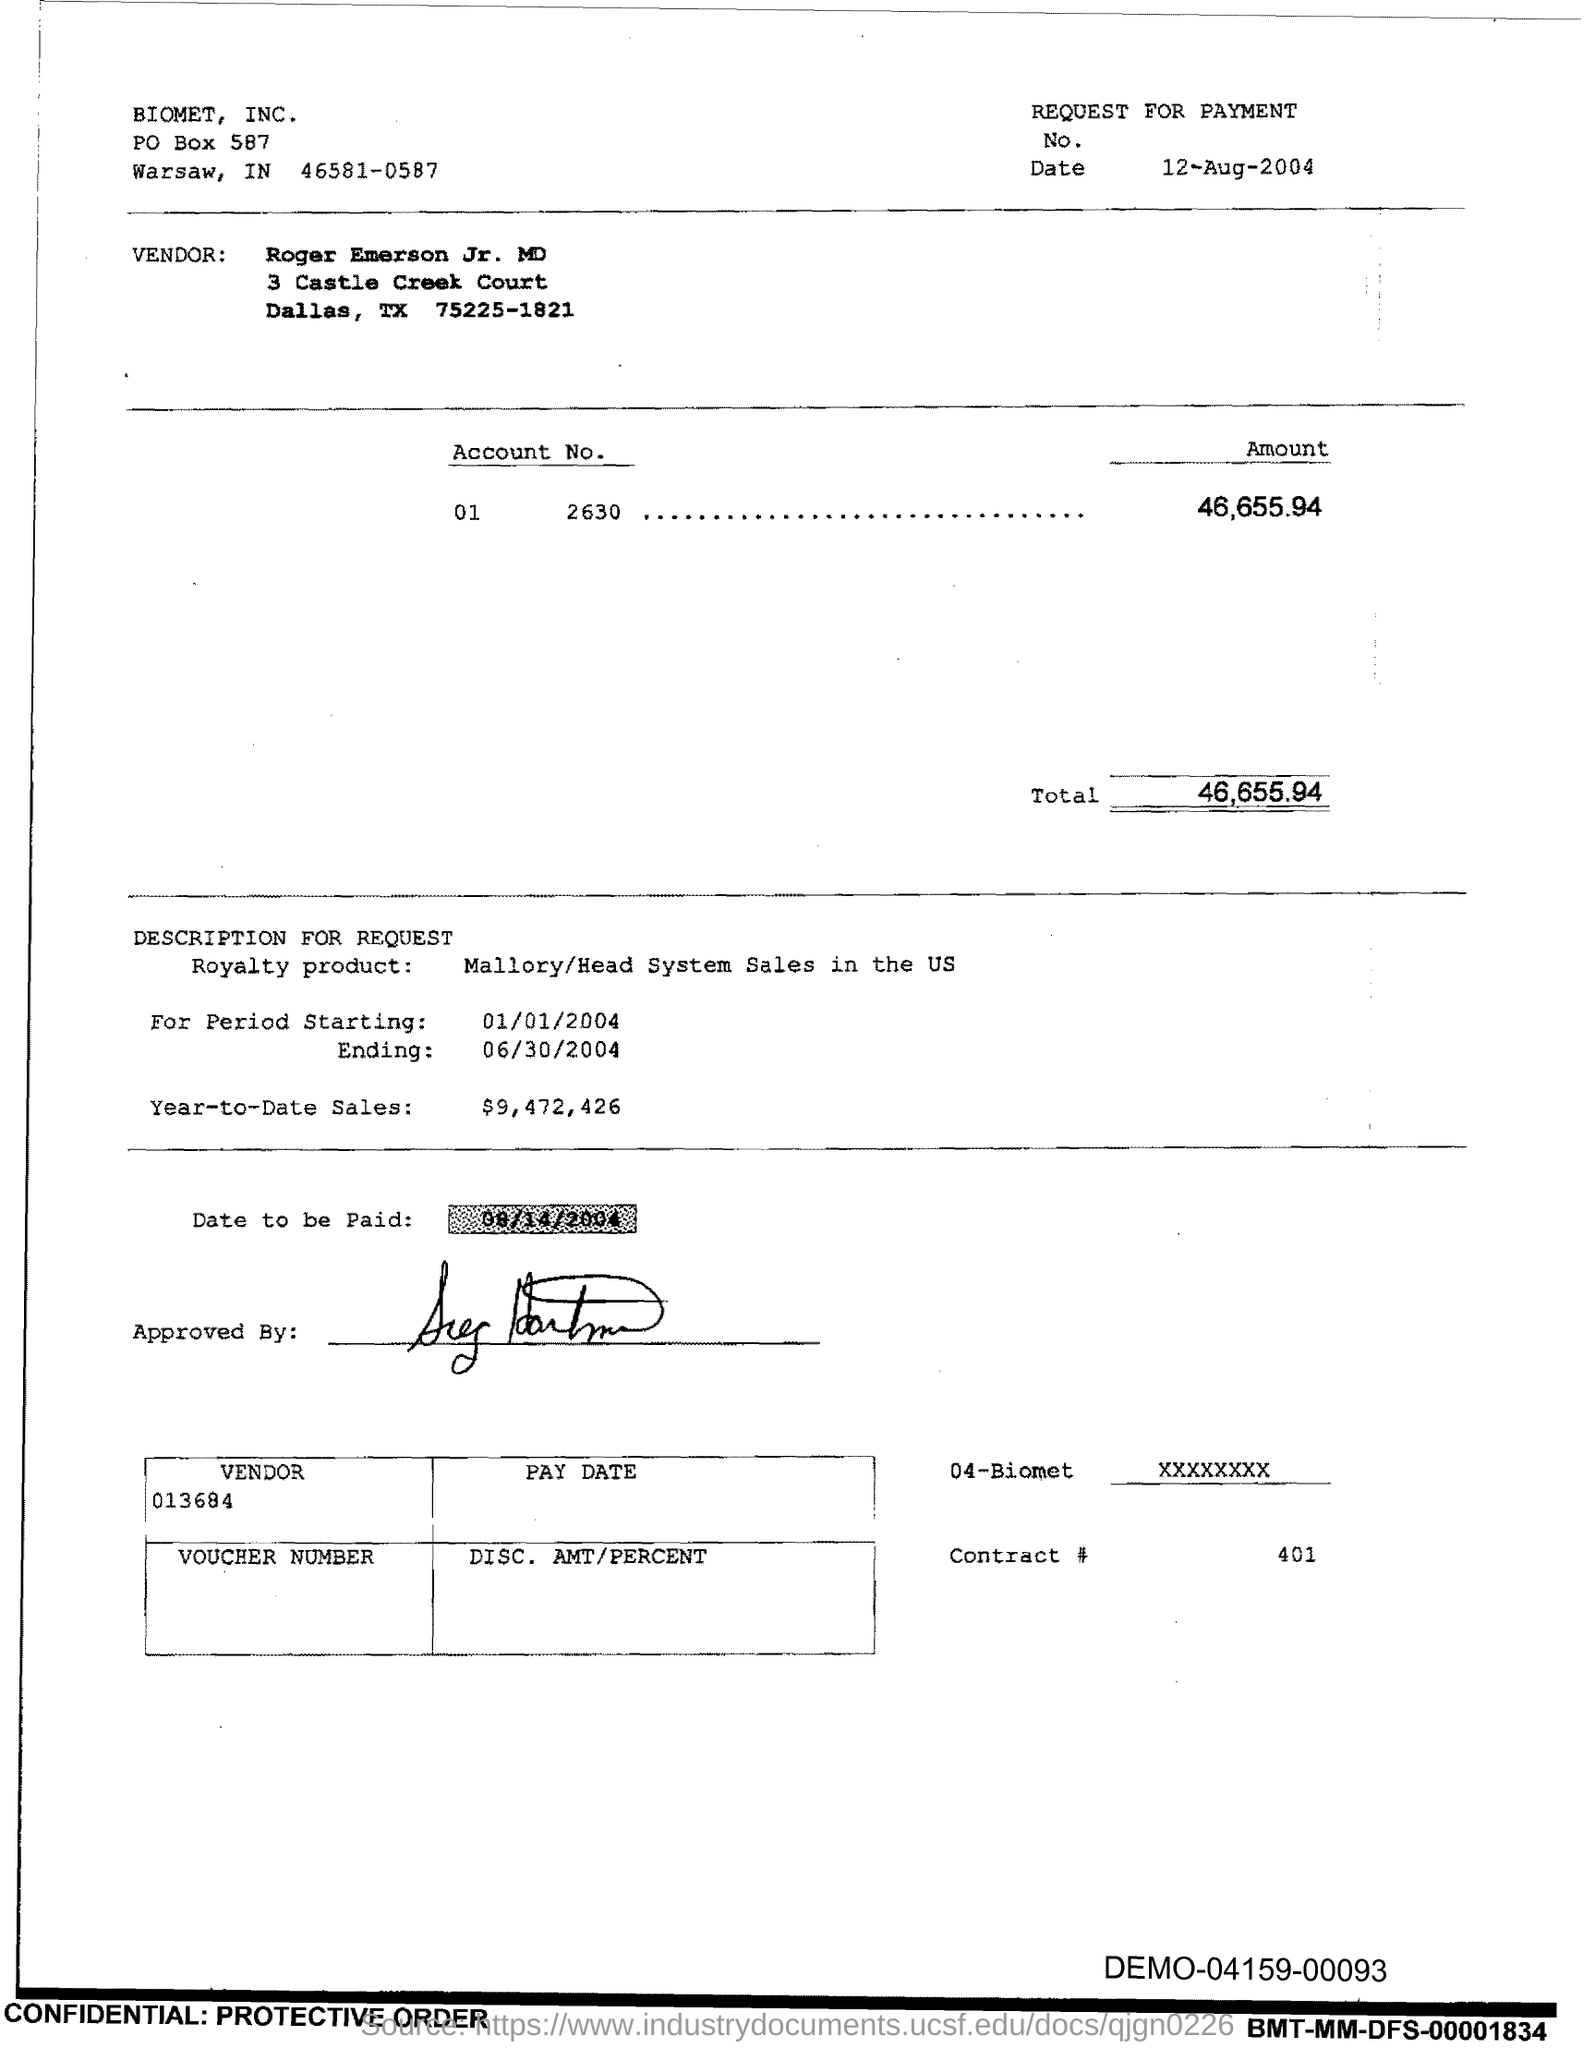What is the total ?
Provide a succinct answer. 46,655.94. What is the contract #?
Your answer should be compact. 401. What is the year-to-date sales?
Make the answer very short. $9,472,426. 